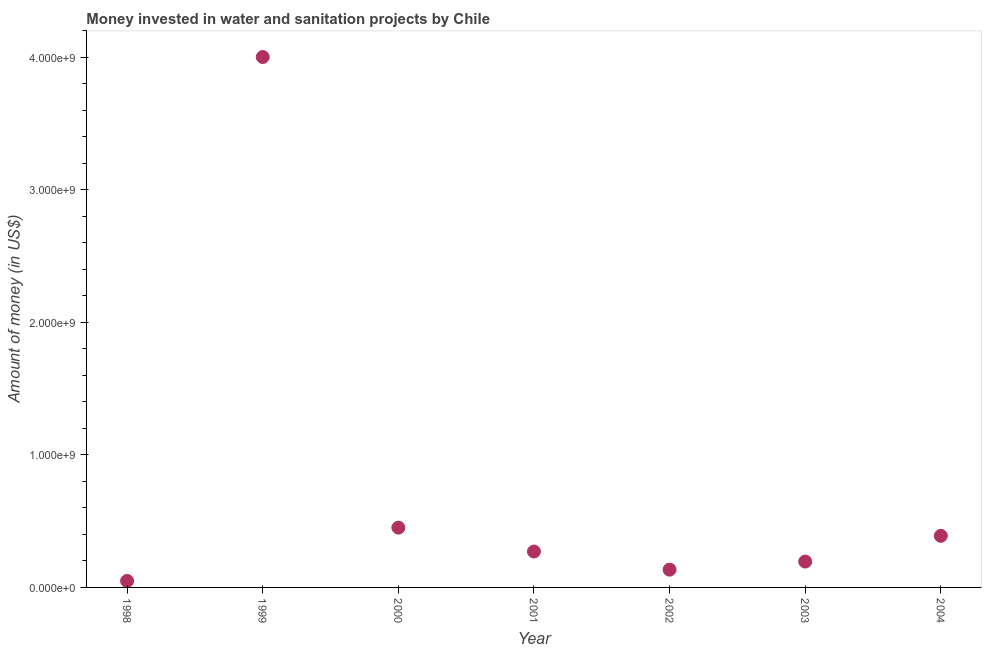What is the investment in 2003?
Ensure brevity in your answer.  1.95e+08. Across all years, what is the maximum investment?
Keep it short and to the point. 4.00e+09. Across all years, what is the minimum investment?
Give a very brief answer. 4.90e+07. In which year was the investment maximum?
Offer a terse response. 1999. What is the sum of the investment?
Make the answer very short. 5.49e+09. What is the difference between the investment in 2000 and 2001?
Ensure brevity in your answer.  1.80e+08. What is the average investment per year?
Offer a very short reply. 7.85e+08. What is the median investment?
Offer a very short reply. 2.71e+08. In how many years, is the investment greater than 1400000000 US$?
Your answer should be compact. 1. Do a majority of the years between 2004 and 2000 (inclusive) have investment greater than 1600000000 US$?
Ensure brevity in your answer.  Yes. What is the ratio of the investment in 1998 to that in 1999?
Provide a succinct answer. 0.01. Is the investment in 2003 less than that in 2004?
Provide a succinct answer. Yes. What is the difference between the highest and the second highest investment?
Offer a very short reply. 3.55e+09. What is the difference between the highest and the lowest investment?
Provide a succinct answer. 3.95e+09. Does the investment monotonically increase over the years?
Provide a succinct answer. No. How many dotlines are there?
Give a very brief answer. 1. What is the difference between two consecutive major ticks on the Y-axis?
Make the answer very short. 1.00e+09. Does the graph contain any zero values?
Your response must be concise. No. Does the graph contain grids?
Ensure brevity in your answer.  No. What is the title of the graph?
Your response must be concise. Money invested in water and sanitation projects by Chile. What is the label or title of the X-axis?
Keep it short and to the point. Year. What is the label or title of the Y-axis?
Your answer should be very brief. Amount of money (in US$). What is the Amount of money (in US$) in 1998?
Give a very brief answer. 4.90e+07. What is the Amount of money (in US$) in 1999?
Your answer should be compact. 4.00e+09. What is the Amount of money (in US$) in 2000?
Your answer should be compact. 4.51e+08. What is the Amount of money (in US$) in 2001?
Your answer should be very brief. 2.71e+08. What is the Amount of money (in US$) in 2002?
Offer a terse response. 1.34e+08. What is the Amount of money (in US$) in 2003?
Offer a very short reply. 1.95e+08. What is the Amount of money (in US$) in 2004?
Give a very brief answer. 3.89e+08. What is the difference between the Amount of money (in US$) in 1998 and 1999?
Offer a very short reply. -3.95e+09. What is the difference between the Amount of money (in US$) in 1998 and 2000?
Your answer should be compact. -4.02e+08. What is the difference between the Amount of money (in US$) in 1998 and 2001?
Make the answer very short. -2.22e+08. What is the difference between the Amount of money (in US$) in 1998 and 2002?
Your response must be concise. -8.52e+07. What is the difference between the Amount of money (in US$) in 1998 and 2003?
Offer a terse response. -1.46e+08. What is the difference between the Amount of money (in US$) in 1998 and 2004?
Provide a short and direct response. -3.40e+08. What is the difference between the Amount of money (in US$) in 1999 and 2000?
Offer a terse response. 3.55e+09. What is the difference between the Amount of money (in US$) in 1999 and 2001?
Keep it short and to the point. 3.73e+09. What is the difference between the Amount of money (in US$) in 1999 and 2002?
Ensure brevity in your answer.  3.87e+09. What is the difference between the Amount of money (in US$) in 1999 and 2003?
Provide a succinct answer. 3.81e+09. What is the difference between the Amount of money (in US$) in 1999 and 2004?
Your answer should be very brief. 3.61e+09. What is the difference between the Amount of money (in US$) in 2000 and 2001?
Provide a succinct answer. 1.80e+08. What is the difference between the Amount of money (in US$) in 2000 and 2002?
Keep it short and to the point. 3.17e+08. What is the difference between the Amount of money (in US$) in 2000 and 2003?
Offer a very short reply. 2.56e+08. What is the difference between the Amount of money (in US$) in 2000 and 2004?
Provide a short and direct response. 6.19e+07. What is the difference between the Amount of money (in US$) in 2001 and 2002?
Provide a short and direct response. 1.37e+08. What is the difference between the Amount of money (in US$) in 2001 and 2003?
Offer a very short reply. 7.57e+07. What is the difference between the Amount of money (in US$) in 2001 and 2004?
Offer a terse response. -1.18e+08. What is the difference between the Amount of money (in US$) in 2002 and 2003?
Offer a terse response. -6.11e+07. What is the difference between the Amount of money (in US$) in 2002 and 2004?
Offer a terse response. -2.55e+08. What is the difference between the Amount of money (in US$) in 2003 and 2004?
Your answer should be very brief. -1.94e+08. What is the ratio of the Amount of money (in US$) in 1998 to that in 1999?
Your response must be concise. 0.01. What is the ratio of the Amount of money (in US$) in 1998 to that in 2000?
Ensure brevity in your answer.  0.11. What is the ratio of the Amount of money (in US$) in 1998 to that in 2001?
Offer a very short reply. 0.18. What is the ratio of the Amount of money (in US$) in 1998 to that in 2002?
Make the answer very short. 0.36. What is the ratio of the Amount of money (in US$) in 1998 to that in 2003?
Your answer should be compact. 0.25. What is the ratio of the Amount of money (in US$) in 1998 to that in 2004?
Your response must be concise. 0.13. What is the ratio of the Amount of money (in US$) in 1999 to that in 2000?
Offer a terse response. 8.87. What is the ratio of the Amount of money (in US$) in 1999 to that in 2001?
Keep it short and to the point. 14.77. What is the ratio of the Amount of money (in US$) in 1999 to that in 2002?
Ensure brevity in your answer.  29.83. What is the ratio of the Amount of money (in US$) in 1999 to that in 2003?
Ensure brevity in your answer.  20.5. What is the ratio of the Amount of money (in US$) in 1999 to that in 2004?
Provide a short and direct response. 10.28. What is the ratio of the Amount of money (in US$) in 2000 to that in 2001?
Offer a very short reply. 1.67. What is the ratio of the Amount of money (in US$) in 2000 to that in 2002?
Offer a very short reply. 3.36. What is the ratio of the Amount of money (in US$) in 2000 to that in 2003?
Provide a short and direct response. 2.31. What is the ratio of the Amount of money (in US$) in 2000 to that in 2004?
Provide a succinct answer. 1.16. What is the ratio of the Amount of money (in US$) in 2001 to that in 2002?
Make the answer very short. 2.02. What is the ratio of the Amount of money (in US$) in 2001 to that in 2003?
Ensure brevity in your answer.  1.39. What is the ratio of the Amount of money (in US$) in 2001 to that in 2004?
Offer a terse response. 0.7. What is the ratio of the Amount of money (in US$) in 2002 to that in 2003?
Your answer should be very brief. 0.69. What is the ratio of the Amount of money (in US$) in 2002 to that in 2004?
Keep it short and to the point. 0.34. What is the ratio of the Amount of money (in US$) in 2003 to that in 2004?
Your answer should be very brief. 0.5. 